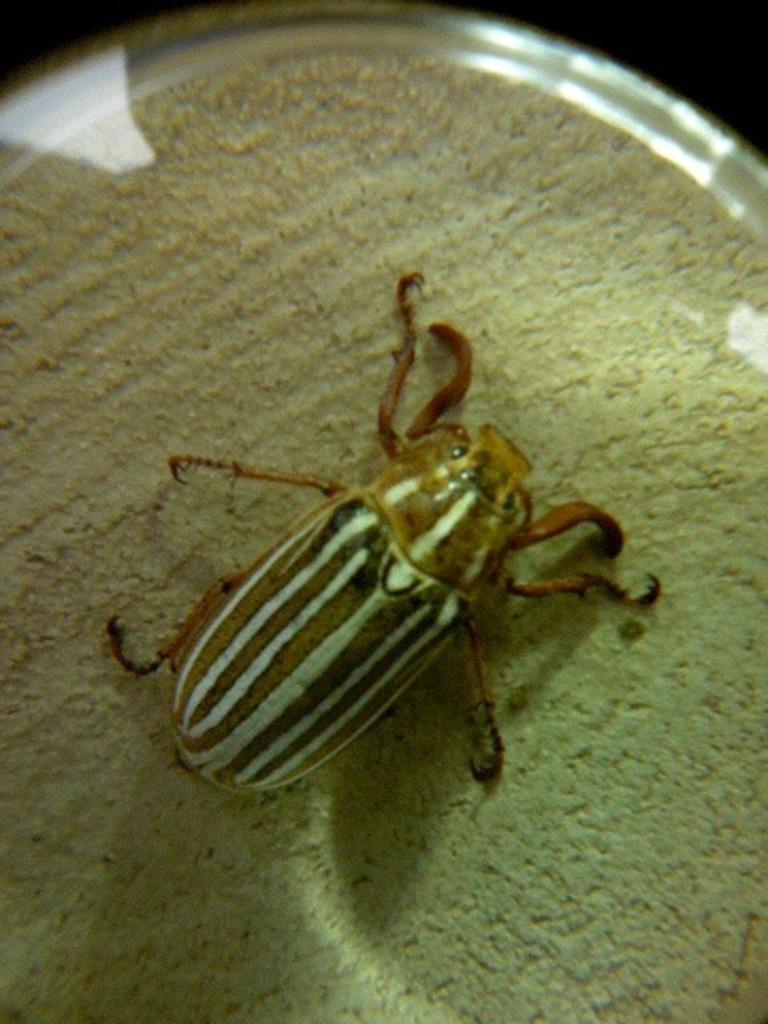How would you summarize this image in a sentence or two? In this image there is an insect on the floor. 